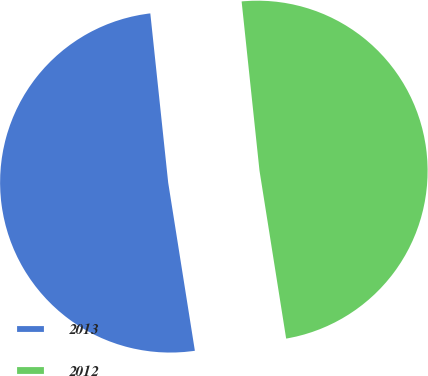Convert chart to OTSL. <chart><loc_0><loc_0><loc_500><loc_500><pie_chart><fcel>2013<fcel>2012<nl><fcel>50.83%<fcel>49.17%<nl></chart> 